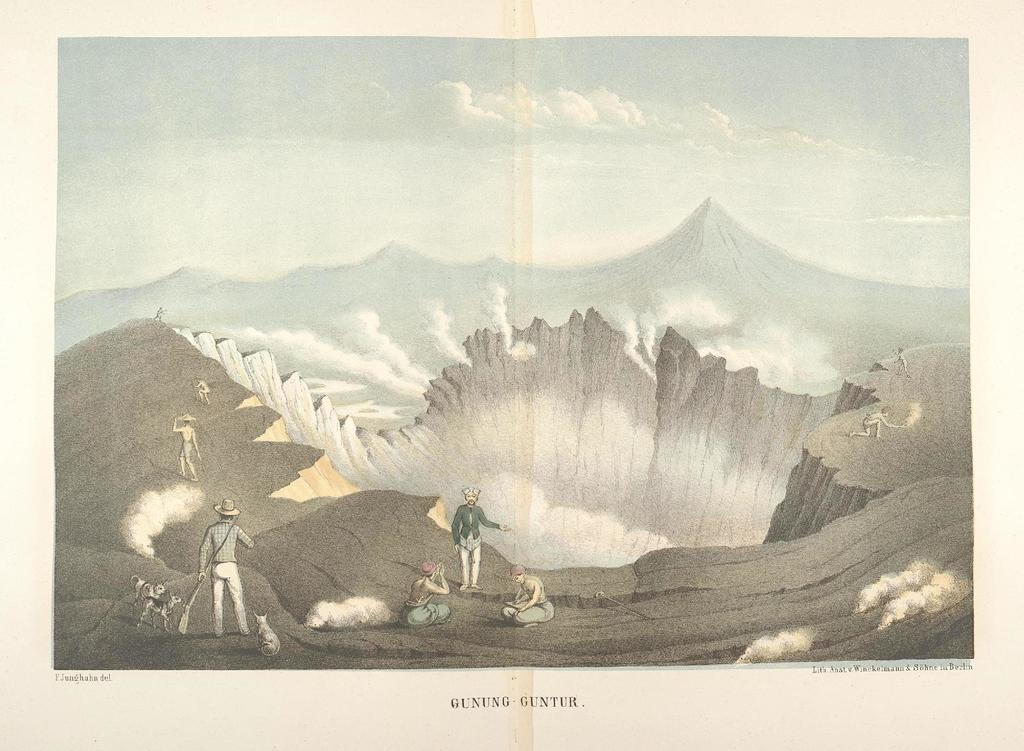What is the main subject of the image? The main subject of the image is a group of people sitting and standing on a mountain. What type of material is visible in the image? There is photograph paper in the image. What can be seen in the background of the image? The sky is visible in the image, and clouds are present. Are there any giants visible in the image? No, there are no giants present in the image. What type of authority is being exercised by the people in the image? The image does not provide any information about authority being exercised by the people. 